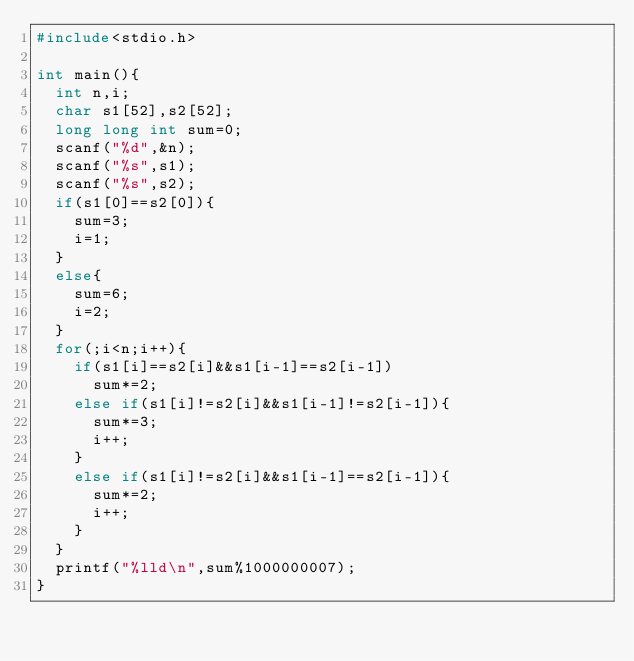<code> <loc_0><loc_0><loc_500><loc_500><_C_>#include<stdio.h>

int main(){
  int n,i;
  char s1[52],s2[52];
  long long int sum=0;
  scanf("%d",&n);
  scanf("%s",s1);
  scanf("%s",s2);
  if(s1[0]==s2[0]){
    sum=3;
    i=1;
  }
  else{
    sum=6;
    i=2;
  }
  for(;i<n;i++){
    if(s1[i]==s2[i]&&s1[i-1]==s2[i-1])
      sum*=2;
    else if(s1[i]!=s2[i]&&s1[i-1]!=s2[i-1]){
      sum*=3;
      i++;
    }
    else if(s1[i]!=s2[i]&&s1[i-1]==s2[i-1]){
      sum*=2;
      i++;
    }
  }
  printf("%lld\n",sum%1000000007);
}</code> 